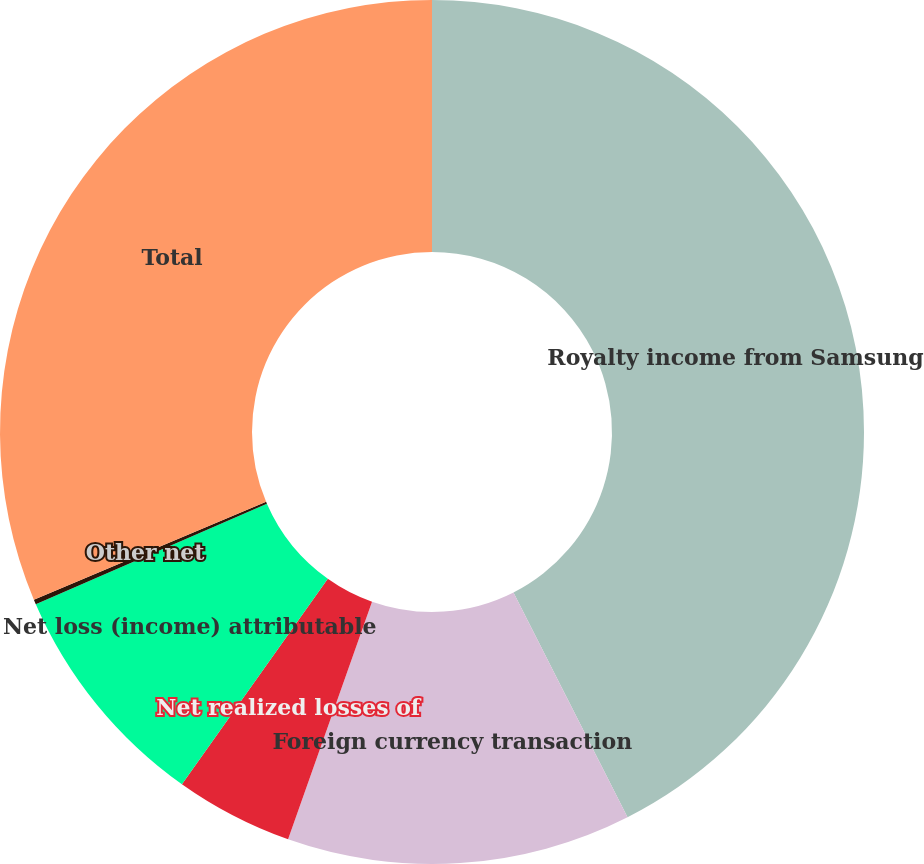Convert chart to OTSL. <chart><loc_0><loc_0><loc_500><loc_500><pie_chart><fcel>Royalty income from Samsung<fcel>Foreign currency transaction<fcel>Net realized losses of<fcel>Net loss (income) attributable<fcel>Other net<fcel>Total<nl><fcel>42.52%<fcel>12.88%<fcel>4.42%<fcel>8.65%<fcel>0.18%<fcel>31.34%<nl></chart> 